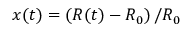Convert formula to latex. <formula><loc_0><loc_0><loc_500><loc_500>x ( t ) = \left ( R ( t ) - R _ { 0 } \right ) / R _ { 0 }</formula> 